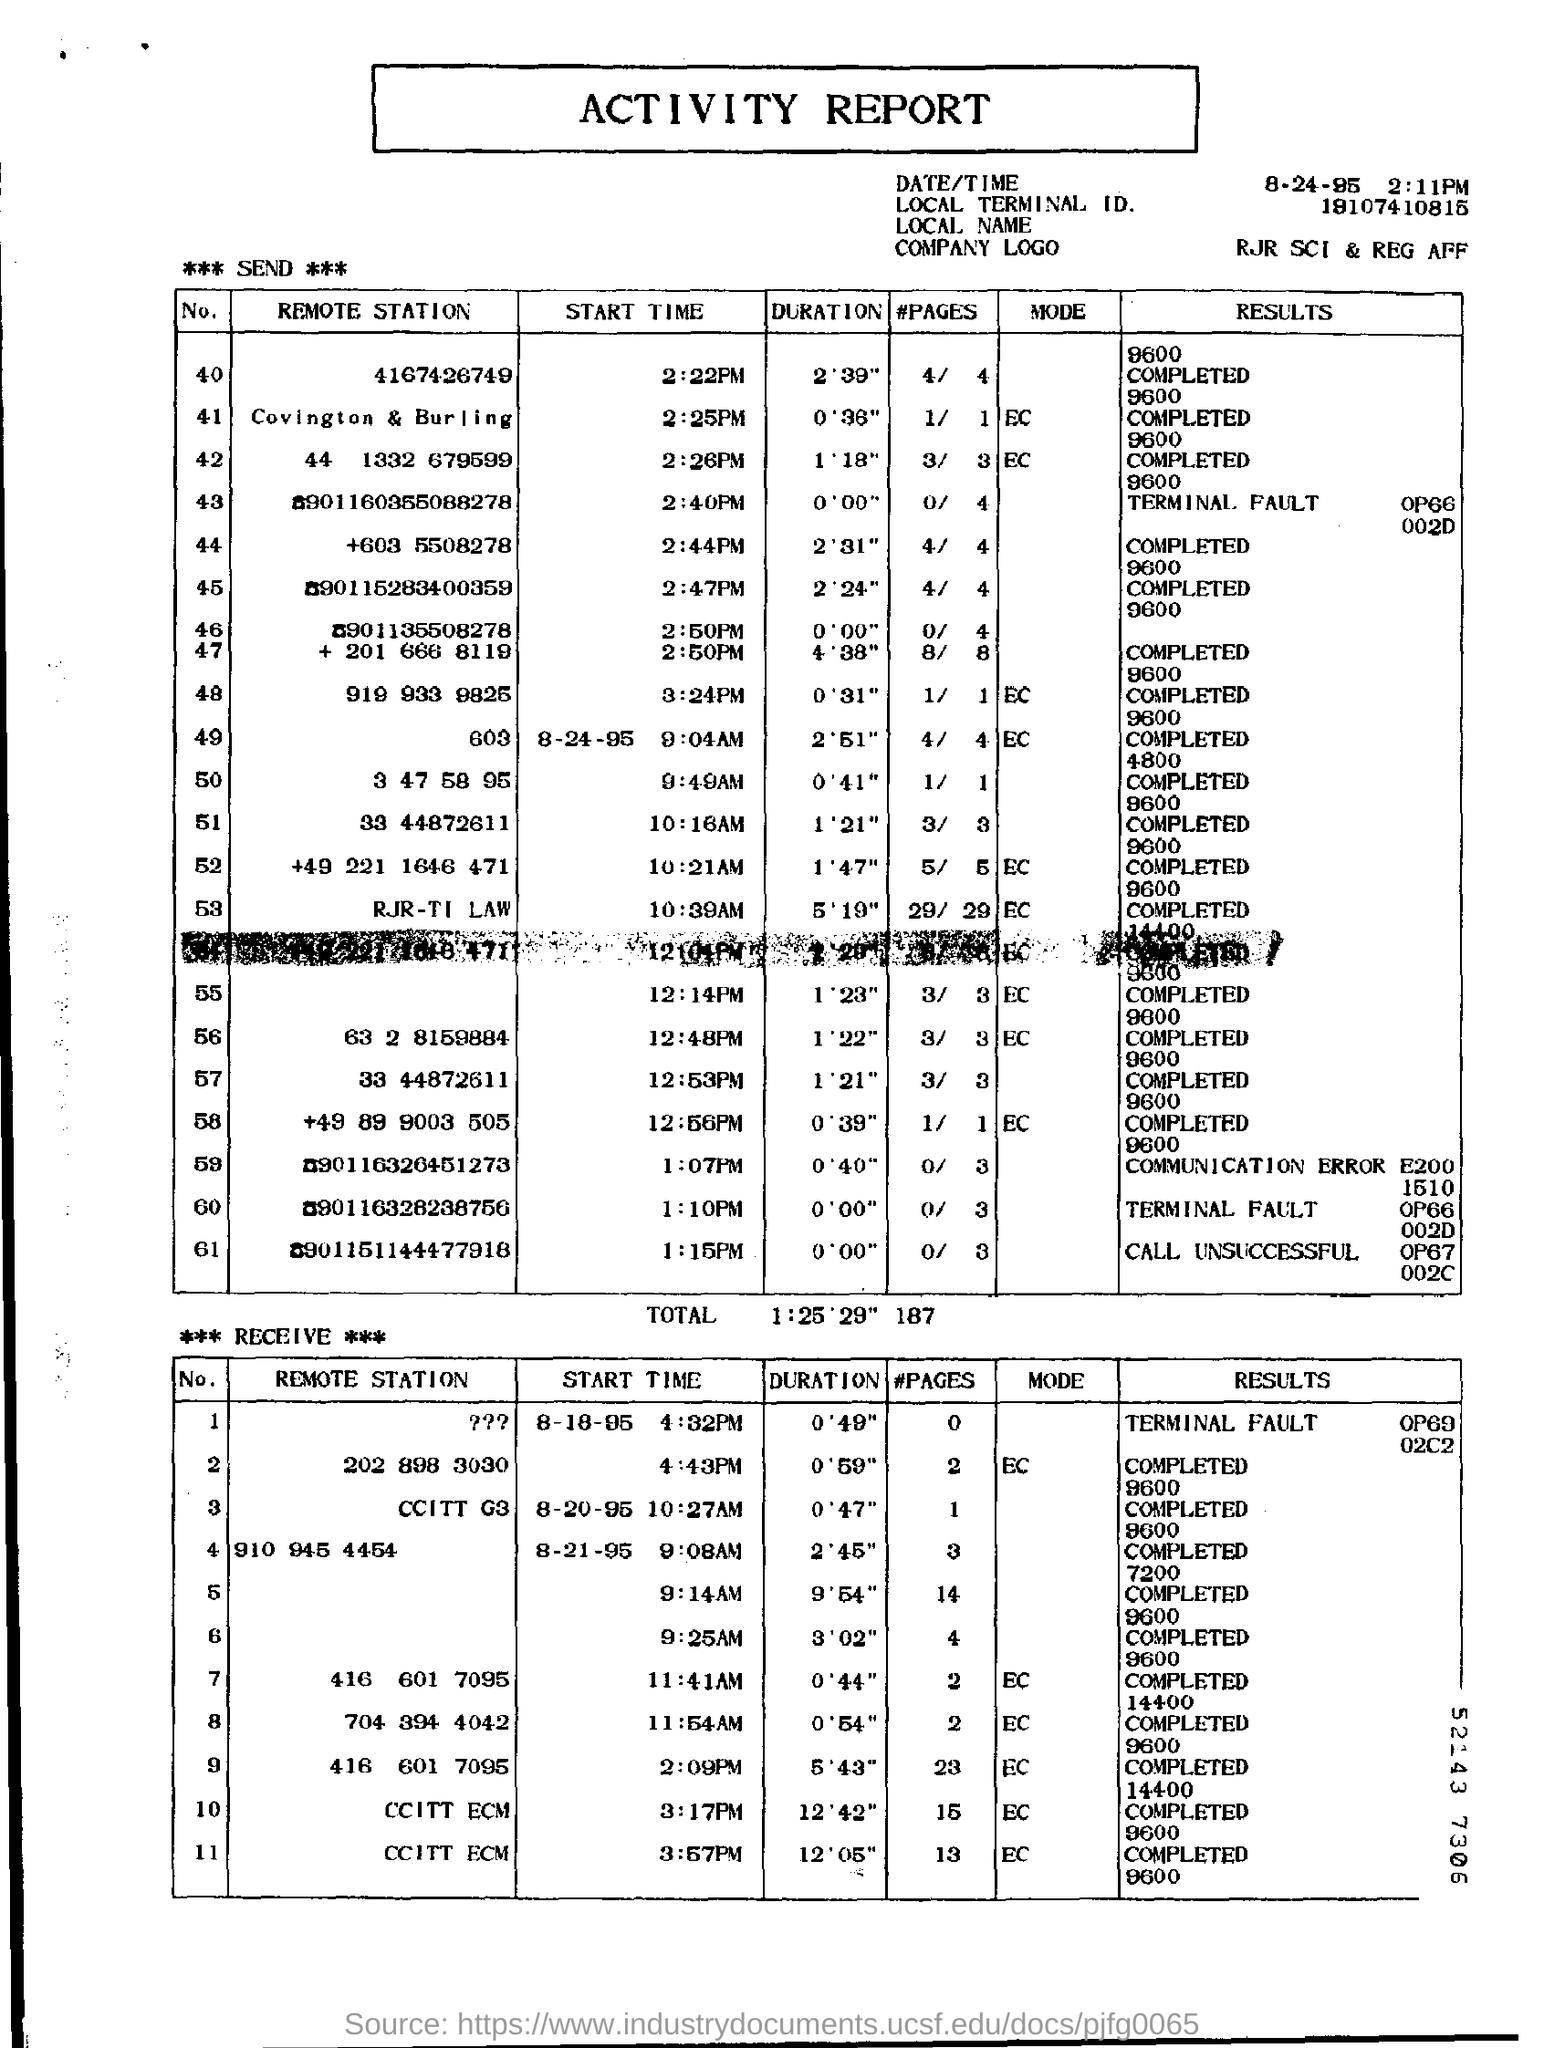Specify some key components in this picture. The duration of Remote Station 4167426749 is 2 minutes and 39 seconds. 